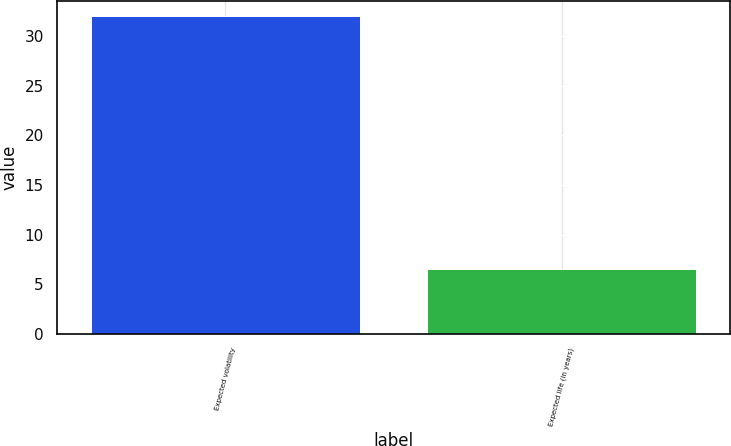Convert chart. <chart><loc_0><loc_0><loc_500><loc_500><bar_chart><fcel>Expected volatility<fcel>Expected life (in years)<nl><fcel>32<fcel>6.5<nl></chart> 